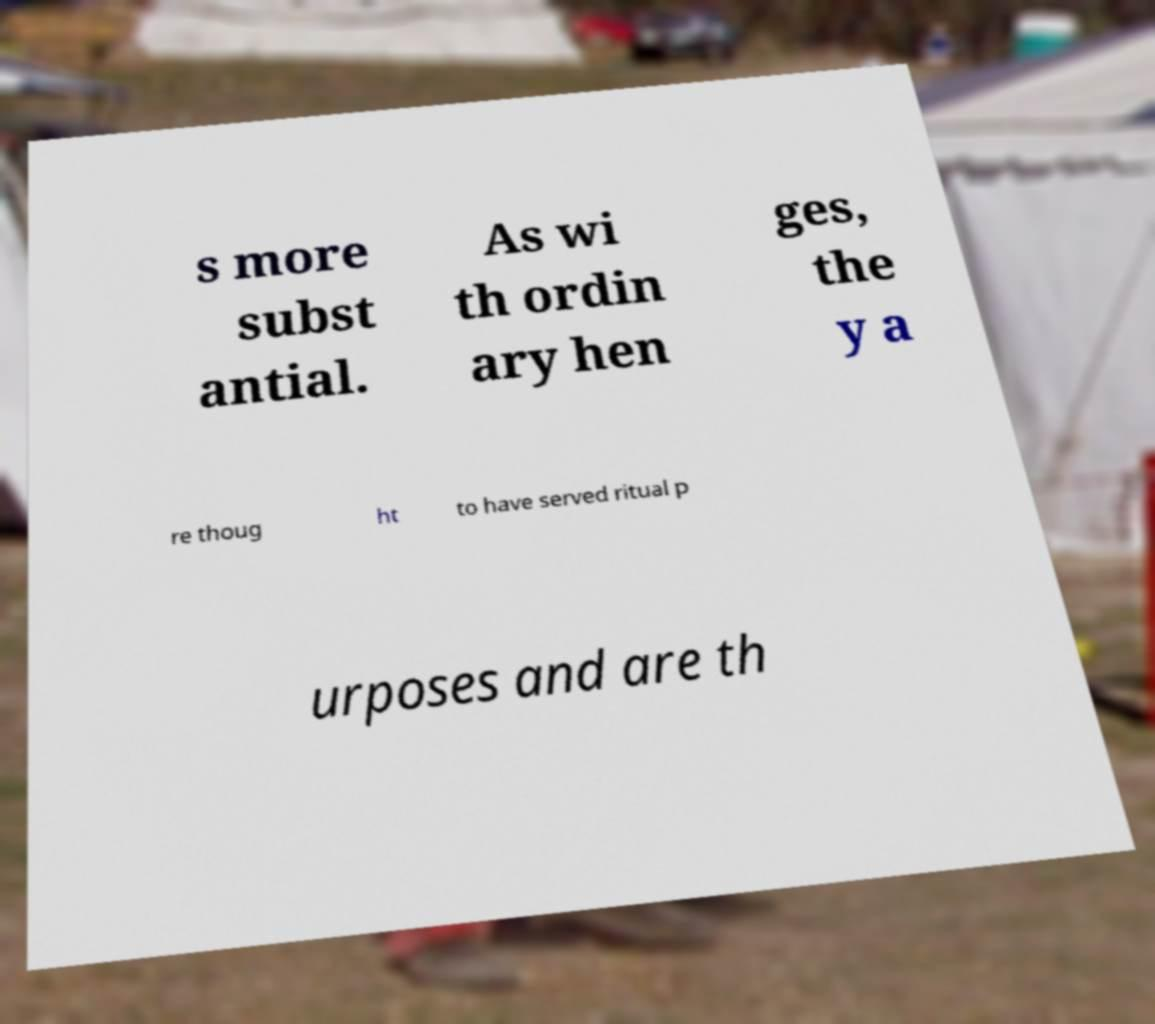Could you assist in decoding the text presented in this image and type it out clearly? s more subst antial. As wi th ordin ary hen ges, the y a re thoug ht to have served ritual p urposes and are th 